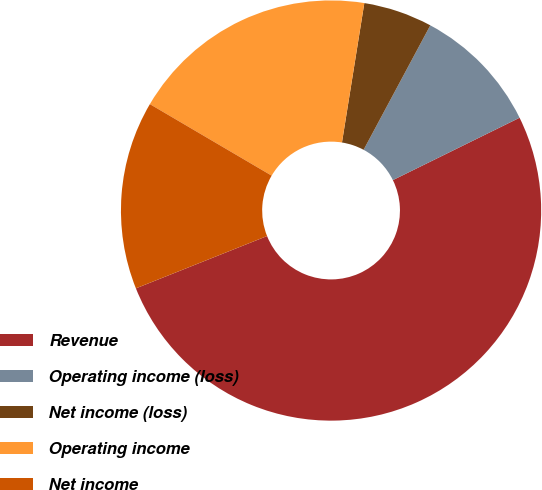Convert chart to OTSL. <chart><loc_0><loc_0><loc_500><loc_500><pie_chart><fcel>Revenue<fcel>Operating income (loss)<fcel>Net income (loss)<fcel>Operating income<fcel>Net income<nl><fcel>51.24%<fcel>9.89%<fcel>5.3%<fcel>19.08%<fcel>14.49%<nl></chart> 